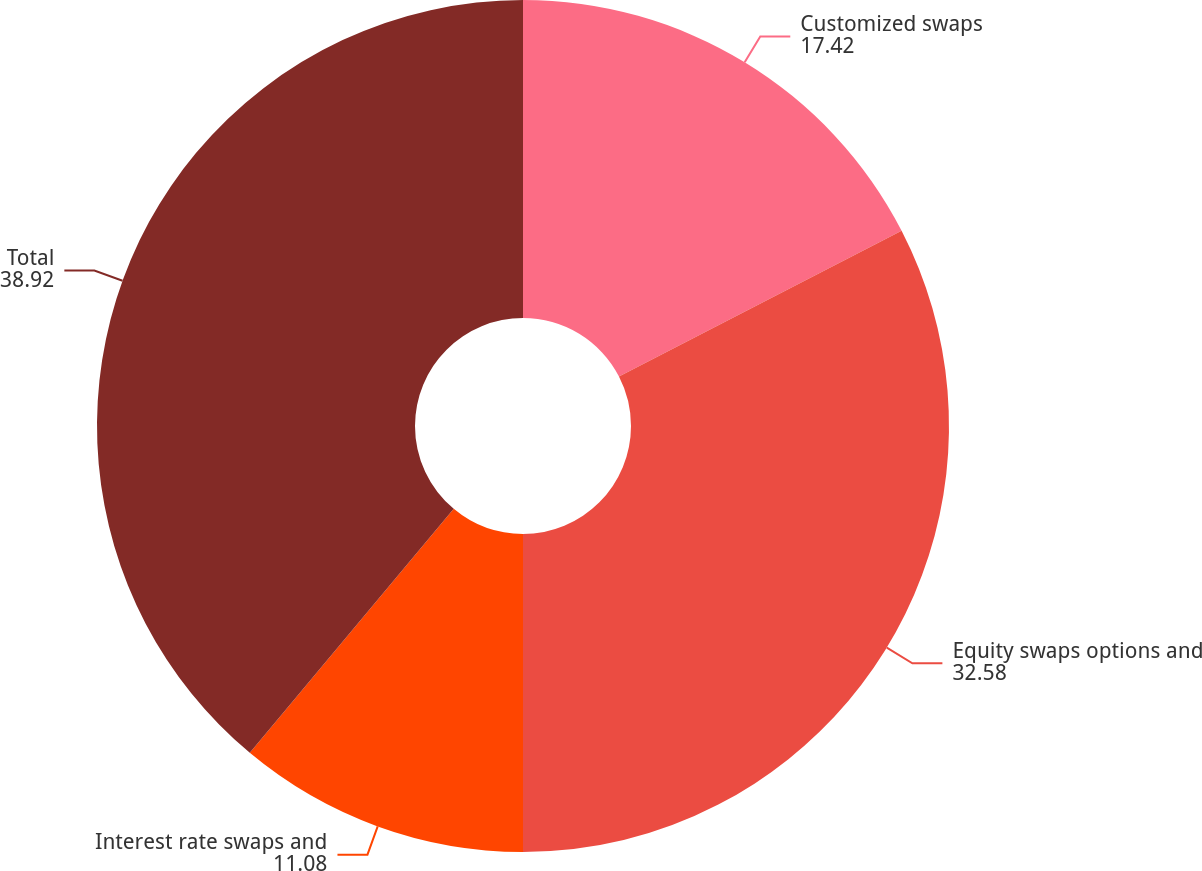Convert chart. <chart><loc_0><loc_0><loc_500><loc_500><pie_chart><fcel>Customized swaps<fcel>Equity swaps options and<fcel>Interest rate swaps and<fcel>Total<nl><fcel>17.42%<fcel>32.58%<fcel>11.08%<fcel>38.92%<nl></chart> 